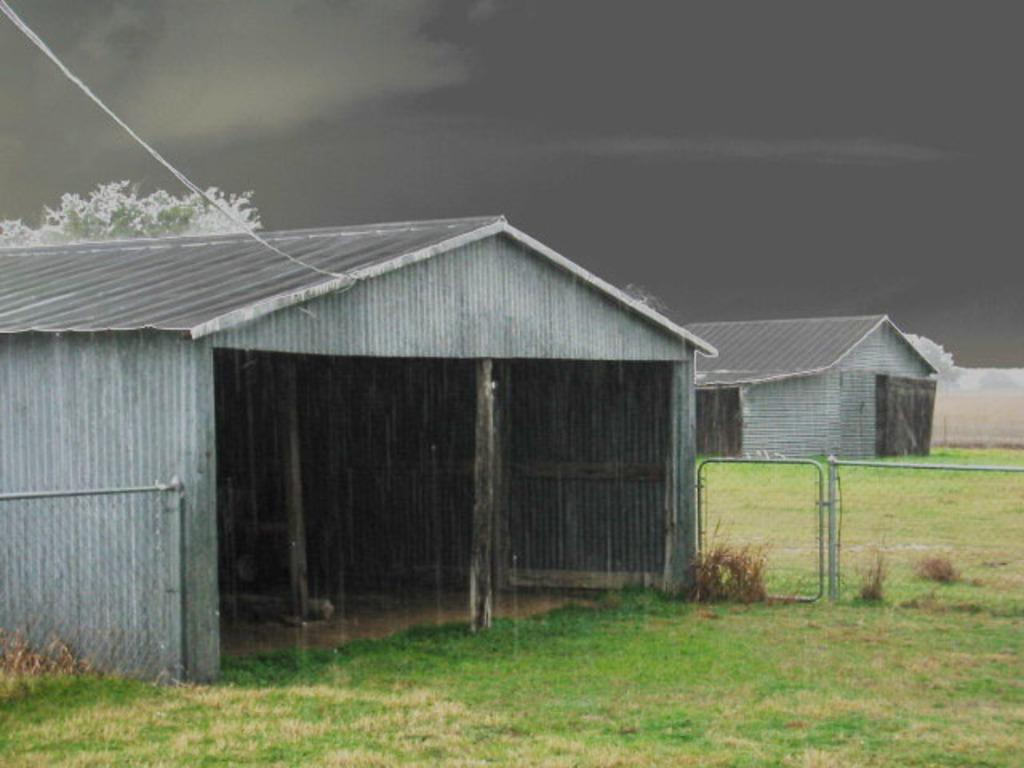How many sheds can be seen in the image? There are two sheds in the image. What is the location of the sheds? The sheds are on a land. How are the sheds separated from each other? The sheds are separated by fencing. What is the condition of the sky in the background of the image? The sky in the background of the image is cloudy. How many plates are being smashed by the lizards in the image? There are no lizards or plates present in the image. 